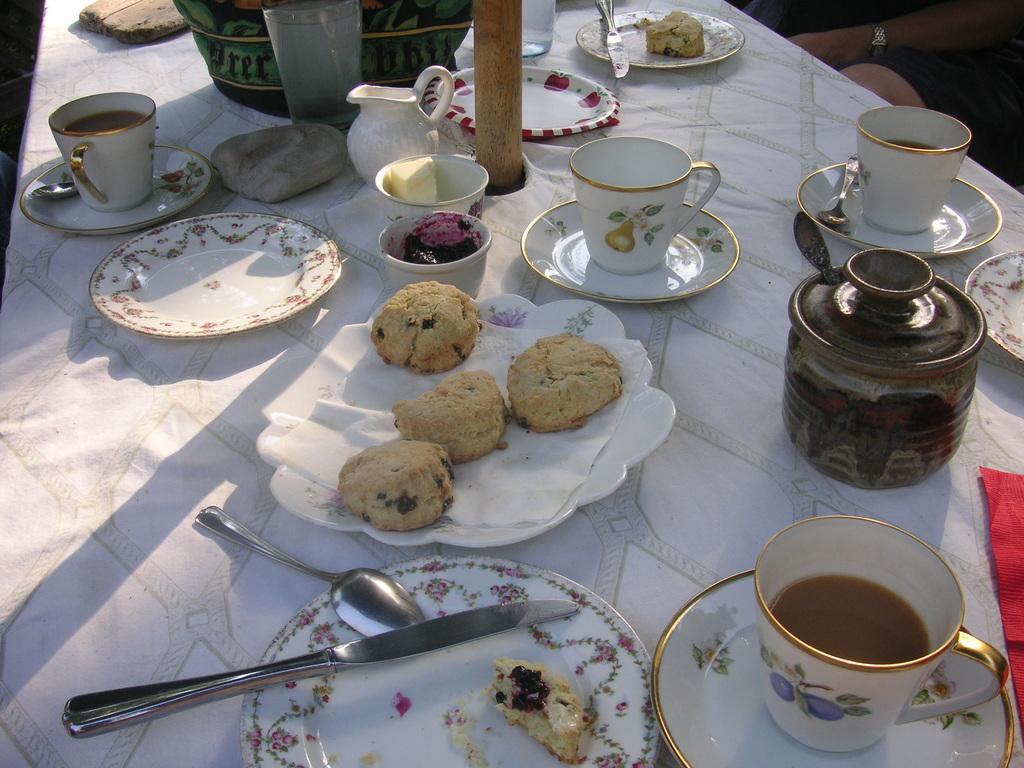Please provide a concise description of this image. on a table there are plates, cup, saucer, spoon, knife, cookies, butter, tissue paper. at the right people are sitting. on the table there is white tablecloth. 